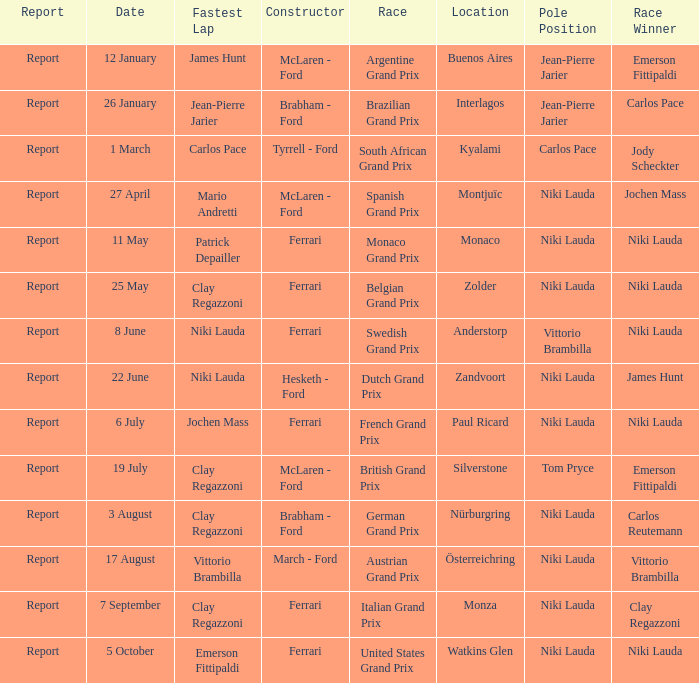Who ran the fastest lap in the team that competed in Zolder, in which Ferrari was the Constructor? Clay Regazzoni. 